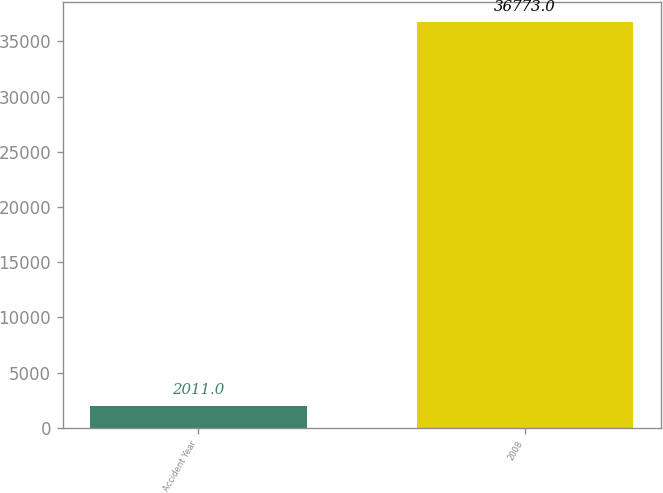Convert chart. <chart><loc_0><loc_0><loc_500><loc_500><bar_chart><fcel>Accident Year<fcel>2008<nl><fcel>2011<fcel>36773<nl></chart> 